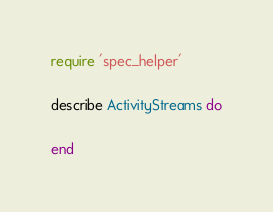Convert code to text. <code><loc_0><loc_0><loc_500><loc_500><_Ruby_>require 'spec_helper'

describe ActivityStreams do

end
</code> 